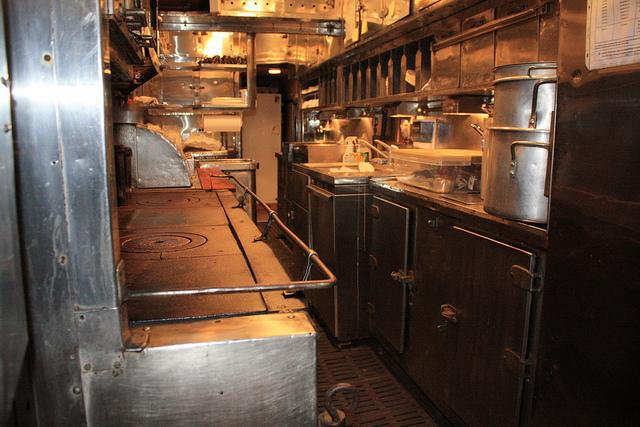What kind of setting is this venue?

Choices:
A) laboratory
B) domestic kitchen
C) factory
D) commercial kitchen commercial kitchen 